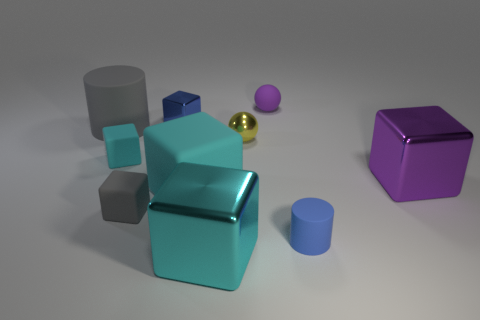Subtract all green cylinders. How many cyan cubes are left? 3 Subtract all large purple metal blocks. How many blocks are left? 5 Subtract all purple cubes. How many cubes are left? 5 Subtract all purple cubes. Subtract all cyan cylinders. How many cubes are left? 5 Subtract all cylinders. How many objects are left? 8 Add 9 large purple metallic objects. How many large purple metallic objects are left? 10 Add 9 large green matte cylinders. How many large green matte cylinders exist? 9 Subtract 0 cyan balls. How many objects are left? 10 Subtract all blue shiny things. Subtract all yellow blocks. How many objects are left? 9 